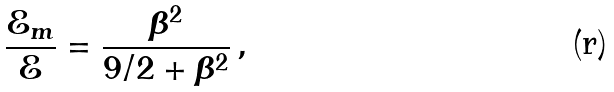Convert formula to latex. <formula><loc_0><loc_0><loc_500><loc_500>\frac { \mathcal { E } _ { m } } { \mathcal { E } } = \frac { \beta ^ { 2 } } { 9 / 2 + \beta ^ { 2 } } \, ,</formula> 